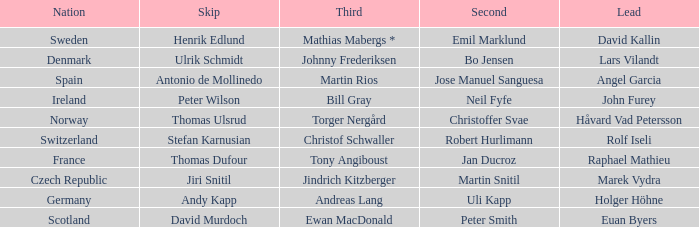Which Lead has a Nation of switzerland? Rolf Iseli. 